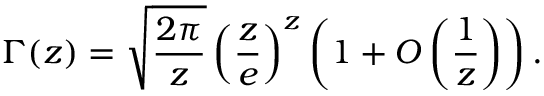Convert formula to latex. <formula><loc_0><loc_0><loc_500><loc_500>\Gamma ( z ) = { \sqrt { \frac { 2 \pi } { z } } } \, { \left ( { \frac { z } { e } } \right ) } ^ { z } \left ( 1 + O \left ( { \frac { 1 } { z } } \right ) \right ) .</formula> 